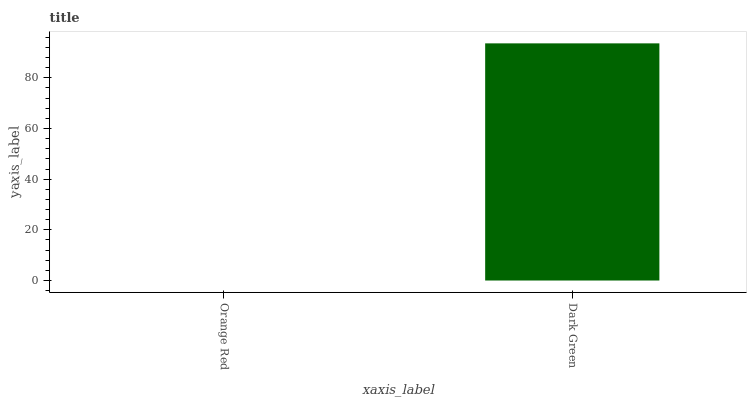Is Dark Green the minimum?
Answer yes or no. No. Is Dark Green greater than Orange Red?
Answer yes or no. Yes. Is Orange Red less than Dark Green?
Answer yes or no. Yes. Is Orange Red greater than Dark Green?
Answer yes or no. No. Is Dark Green less than Orange Red?
Answer yes or no. No. Is Dark Green the high median?
Answer yes or no. Yes. Is Orange Red the low median?
Answer yes or no. Yes. Is Orange Red the high median?
Answer yes or no. No. Is Dark Green the low median?
Answer yes or no. No. 